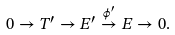<formula> <loc_0><loc_0><loc_500><loc_500>0 \to T ^ { \prime } \to E ^ { \prime } \overset { \phi ^ { \prime } } { \to } E \to 0 .</formula> 